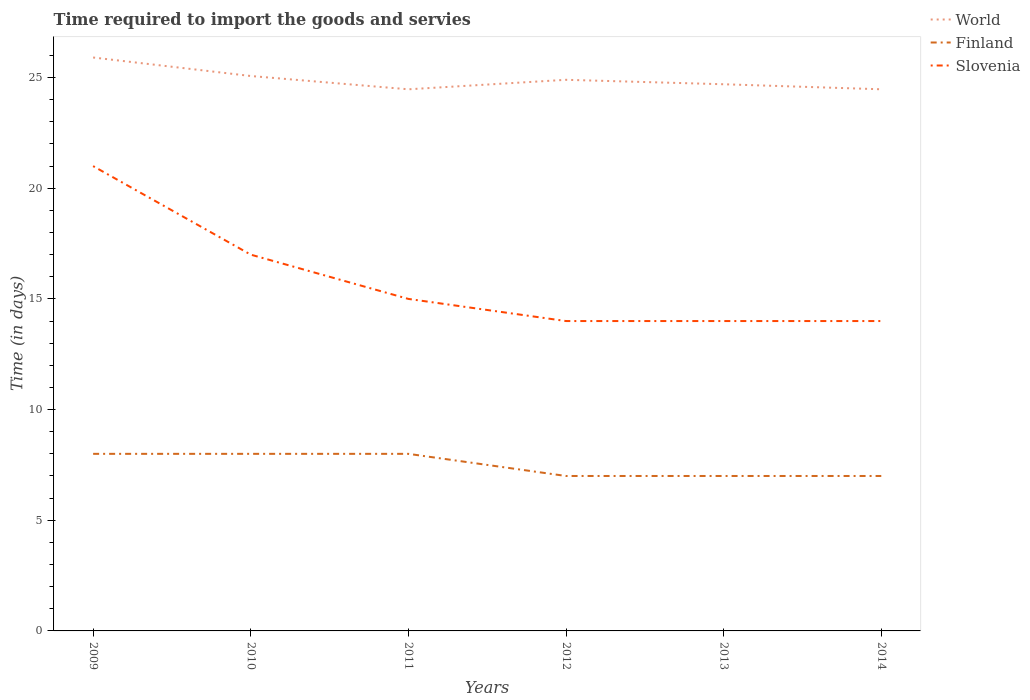How many different coloured lines are there?
Make the answer very short. 3. Does the line corresponding to World intersect with the line corresponding to Finland?
Provide a succinct answer. No. Across all years, what is the maximum number of days required to import the goods and services in Slovenia?
Ensure brevity in your answer.  14. What is the total number of days required to import the goods and services in Slovenia in the graph?
Keep it short and to the point. 4. What is the difference between the highest and the second highest number of days required to import the goods and services in Slovenia?
Keep it short and to the point. 7. What is the difference between the highest and the lowest number of days required to import the goods and services in World?
Provide a succinct answer. 2. How many lines are there?
Provide a succinct answer. 3. How many years are there in the graph?
Make the answer very short. 6. Does the graph contain grids?
Ensure brevity in your answer.  No. How are the legend labels stacked?
Your answer should be compact. Vertical. What is the title of the graph?
Ensure brevity in your answer.  Time required to import the goods and servies. Does "Bhutan" appear as one of the legend labels in the graph?
Provide a short and direct response. No. What is the label or title of the X-axis?
Your answer should be compact. Years. What is the label or title of the Y-axis?
Offer a terse response. Time (in days). What is the Time (in days) of World in 2009?
Your response must be concise. 25.91. What is the Time (in days) in Finland in 2009?
Keep it short and to the point. 8. What is the Time (in days) in Slovenia in 2009?
Make the answer very short. 21. What is the Time (in days) of World in 2010?
Keep it short and to the point. 25.07. What is the Time (in days) of Slovenia in 2010?
Your answer should be compact. 17. What is the Time (in days) in World in 2011?
Ensure brevity in your answer.  24.47. What is the Time (in days) in Finland in 2011?
Your response must be concise. 8. What is the Time (in days) in Slovenia in 2011?
Keep it short and to the point. 15. What is the Time (in days) of World in 2012?
Provide a short and direct response. 24.9. What is the Time (in days) in Finland in 2012?
Your answer should be very brief. 7. What is the Time (in days) in World in 2013?
Ensure brevity in your answer.  24.7. What is the Time (in days) of Slovenia in 2013?
Your answer should be very brief. 14. What is the Time (in days) of World in 2014?
Provide a succinct answer. 24.47. What is the Time (in days) of Finland in 2014?
Keep it short and to the point. 7. What is the Time (in days) of Slovenia in 2014?
Your answer should be very brief. 14. Across all years, what is the maximum Time (in days) in World?
Provide a short and direct response. 25.91. Across all years, what is the maximum Time (in days) of Finland?
Give a very brief answer. 8. Across all years, what is the maximum Time (in days) of Slovenia?
Offer a terse response. 21. Across all years, what is the minimum Time (in days) of World?
Give a very brief answer. 24.47. Across all years, what is the minimum Time (in days) of Slovenia?
Ensure brevity in your answer.  14. What is the total Time (in days) in World in the graph?
Ensure brevity in your answer.  149.52. What is the difference between the Time (in days) of World in 2009 and that in 2010?
Provide a short and direct response. 0.84. What is the difference between the Time (in days) in Slovenia in 2009 and that in 2010?
Your response must be concise. 4. What is the difference between the Time (in days) of World in 2009 and that in 2011?
Offer a very short reply. 1.44. What is the difference between the Time (in days) in Finland in 2009 and that in 2011?
Your answer should be compact. 0. What is the difference between the Time (in days) in Slovenia in 2009 and that in 2011?
Provide a succinct answer. 6. What is the difference between the Time (in days) of World in 2009 and that in 2012?
Your response must be concise. 1.01. What is the difference between the Time (in days) in Finland in 2009 and that in 2012?
Your response must be concise. 1. What is the difference between the Time (in days) of Slovenia in 2009 and that in 2012?
Offer a very short reply. 7. What is the difference between the Time (in days) in World in 2009 and that in 2013?
Keep it short and to the point. 1.21. What is the difference between the Time (in days) of Finland in 2009 and that in 2013?
Give a very brief answer. 1. What is the difference between the Time (in days) of Slovenia in 2009 and that in 2013?
Make the answer very short. 7. What is the difference between the Time (in days) of World in 2009 and that in 2014?
Make the answer very short. 1.44. What is the difference between the Time (in days) of Finland in 2009 and that in 2014?
Offer a very short reply. 1. What is the difference between the Time (in days) in World in 2010 and that in 2011?
Your answer should be very brief. 0.6. What is the difference between the Time (in days) in Finland in 2010 and that in 2011?
Provide a short and direct response. 0. What is the difference between the Time (in days) in World in 2010 and that in 2012?
Ensure brevity in your answer.  0.17. What is the difference between the Time (in days) of Finland in 2010 and that in 2012?
Your response must be concise. 1. What is the difference between the Time (in days) in Slovenia in 2010 and that in 2012?
Provide a short and direct response. 3. What is the difference between the Time (in days) of World in 2010 and that in 2013?
Your response must be concise. 0.37. What is the difference between the Time (in days) in Finland in 2010 and that in 2013?
Your response must be concise. 1. What is the difference between the Time (in days) in World in 2010 and that in 2014?
Your answer should be compact. 0.6. What is the difference between the Time (in days) of Slovenia in 2010 and that in 2014?
Offer a very short reply. 3. What is the difference between the Time (in days) in World in 2011 and that in 2012?
Offer a terse response. -0.43. What is the difference between the Time (in days) in Finland in 2011 and that in 2012?
Offer a terse response. 1. What is the difference between the Time (in days) of Slovenia in 2011 and that in 2012?
Your answer should be very brief. 1. What is the difference between the Time (in days) of World in 2011 and that in 2013?
Offer a terse response. -0.23. What is the difference between the Time (in days) of Finland in 2011 and that in 2013?
Your answer should be compact. 1. What is the difference between the Time (in days) in World in 2011 and that in 2014?
Give a very brief answer. -0. What is the difference between the Time (in days) of Slovenia in 2011 and that in 2014?
Ensure brevity in your answer.  1. What is the difference between the Time (in days) of World in 2012 and that in 2013?
Provide a succinct answer. 0.2. What is the difference between the Time (in days) in Finland in 2012 and that in 2013?
Give a very brief answer. 0. What is the difference between the Time (in days) of World in 2012 and that in 2014?
Make the answer very short. 0.43. What is the difference between the Time (in days) in Finland in 2012 and that in 2014?
Provide a short and direct response. 0. What is the difference between the Time (in days) of World in 2013 and that in 2014?
Offer a terse response. 0.23. What is the difference between the Time (in days) in World in 2009 and the Time (in days) in Finland in 2010?
Keep it short and to the point. 17.91. What is the difference between the Time (in days) in World in 2009 and the Time (in days) in Slovenia in 2010?
Offer a very short reply. 8.91. What is the difference between the Time (in days) of World in 2009 and the Time (in days) of Finland in 2011?
Your answer should be very brief. 17.91. What is the difference between the Time (in days) in World in 2009 and the Time (in days) in Slovenia in 2011?
Ensure brevity in your answer.  10.91. What is the difference between the Time (in days) of Finland in 2009 and the Time (in days) of Slovenia in 2011?
Your answer should be very brief. -7. What is the difference between the Time (in days) in World in 2009 and the Time (in days) in Finland in 2012?
Offer a very short reply. 18.91. What is the difference between the Time (in days) in World in 2009 and the Time (in days) in Slovenia in 2012?
Offer a very short reply. 11.91. What is the difference between the Time (in days) in Finland in 2009 and the Time (in days) in Slovenia in 2012?
Make the answer very short. -6. What is the difference between the Time (in days) of World in 2009 and the Time (in days) of Finland in 2013?
Your answer should be very brief. 18.91. What is the difference between the Time (in days) in World in 2009 and the Time (in days) in Slovenia in 2013?
Your answer should be very brief. 11.91. What is the difference between the Time (in days) in Finland in 2009 and the Time (in days) in Slovenia in 2013?
Provide a succinct answer. -6. What is the difference between the Time (in days) of World in 2009 and the Time (in days) of Finland in 2014?
Your response must be concise. 18.91. What is the difference between the Time (in days) of World in 2009 and the Time (in days) of Slovenia in 2014?
Provide a succinct answer. 11.91. What is the difference between the Time (in days) in Finland in 2009 and the Time (in days) in Slovenia in 2014?
Your response must be concise. -6. What is the difference between the Time (in days) in World in 2010 and the Time (in days) in Finland in 2011?
Give a very brief answer. 17.07. What is the difference between the Time (in days) in World in 2010 and the Time (in days) in Slovenia in 2011?
Offer a very short reply. 10.07. What is the difference between the Time (in days) in World in 2010 and the Time (in days) in Finland in 2012?
Ensure brevity in your answer.  18.07. What is the difference between the Time (in days) of World in 2010 and the Time (in days) of Slovenia in 2012?
Ensure brevity in your answer.  11.07. What is the difference between the Time (in days) of Finland in 2010 and the Time (in days) of Slovenia in 2012?
Keep it short and to the point. -6. What is the difference between the Time (in days) in World in 2010 and the Time (in days) in Finland in 2013?
Your answer should be very brief. 18.07. What is the difference between the Time (in days) in World in 2010 and the Time (in days) in Slovenia in 2013?
Ensure brevity in your answer.  11.07. What is the difference between the Time (in days) of World in 2010 and the Time (in days) of Finland in 2014?
Give a very brief answer. 18.07. What is the difference between the Time (in days) in World in 2010 and the Time (in days) in Slovenia in 2014?
Give a very brief answer. 11.07. What is the difference between the Time (in days) in World in 2011 and the Time (in days) in Finland in 2012?
Your answer should be very brief. 17.47. What is the difference between the Time (in days) of World in 2011 and the Time (in days) of Slovenia in 2012?
Provide a short and direct response. 10.47. What is the difference between the Time (in days) of World in 2011 and the Time (in days) of Finland in 2013?
Your answer should be very brief. 17.47. What is the difference between the Time (in days) in World in 2011 and the Time (in days) in Slovenia in 2013?
Make the answer very short. 10.47. What is the difference between the Time (in days) in Finland in 2011 and the Time (in days) in Slovenia in 2013?
Provide a short and direct response. -6. What is the difference between the Time (in days) in World in 2011 and the Time (in days) in Finland in 2014?
Offer a very short reply. 17.47. What is the difference between the Time (in days) in World in 2011 and the Time (in days) in Slovenia in 2014?
Provide a succinct answer. 10.47. What is the difference between the Time (in days) of World in 2012 and the Time (in days) of Finland in 2013?
Offer a very short reply. 17.9. What is the difference between the Time (in days) of World in 2012 and the Time (in days) of Slovenia in 2013?
Make the answer very short. 10.9. What is the difference between the Time (in days) in World in 2012 and the Time (in days) in Finland in 2014?
Make the answer very short. 17.9. What is the difference between the Time (in days) in World in 2012 and the Time (in days) in Slovenia in 2014?
Your response must be concise. 10.9. What is the difference between the Time (in days) of World in 2013 and the Time (in days) of Finland in 2014?
Your response must be concise. 17.7. What is the difference between the Time (in days) of World in 2013 and the Time (in days) of Slovenia in 2014?
Your answer should be compact. 10.7. What is the difference between the Time (in days) in Finland in 2013 and the Time (in days) in Slovenia in 2014?
Give a very brief answer. -7. What is the average Time (in days) in World per year?
Offer a terse response. 24.92. What is the average Time (in days) in Slovenia per year?
Your answer should be very brief. 15.83. In the year 2009, what is the difference between the Time (in days) of World and Time (in days) of Finland?
Provide a short and direct response. 17.91. In the year 2009, what is the difference between the Time (in days) in World and Time (in days) in Slovenia?
Your answer should be very brief. 4.91. In the year 2010, what is the difference between the Time (in days) in World and Time (in days) in Finland?
Your answer should be very brief. 17.07. In the year 2010, what is the difference between the Time (in days) in World and Time (in days) in Slovenia?
Your response must be concise. 8.07. In the year 2010, what is the difference between the Time (in days) of Finland and Time (in days) of Slovenia?
Offer a very short reply. -9. In the year 2011, what is the difference between the Time (in days) in World and Time (in days) in Finland?
Ensure brevity in your answer.  16.47. In the year 2011, what is the difference between the Time (in days) of World and Time (in days) of Slovenia?
Offer a terse response. 9.47. In the year 2012, what is the difference between the Time (in days) of World and Time (in days) of Finland?
Your answer should be very brief. 17.9. In the year 2012, what is the difference between the Time (in days) of World and Time (in days) of Slovenia?
Provide a short and direct response. 10.9. In the year 2012, what is the difference between the Time (in days) in Finland and Time (in days) in Slovenia?
Ensure brevity in your answer.  -7. In the year 2013, what is the difference between the Time (in days) in World and Time (in days) in Finland?
Make the answer very short. 17.7. In the year 2013, what is the difference between the Time (in days) in World and Time (in days) in Slovenia?
Your answer should be very brief. 10.7. In the year 2014, what is the difference between the Time (in days) of World and Time (in days) of Finland?
Keep it short and to the point. 17.47. In the year 2014, what is the difference between the Time (in days) in World and Time (in days) in Slovenia?
Give a very brief answer. 10.47. In the year 2014, what is the difference between the Time (in days) in Finland and Time (in days) in Slovenia?
Keep it short and to the point. -7. What is the ratio of the Time (in days) in World in 2009 to that in 2010?
Keep it short and to the point. 1.03. What is the ratio of the Time (in days) of Slovenia in 2009 to that in 2010?
Ensure brevity in your answer.  1.24. What is the ratio of the Time (in days) of World in 2009 to that in 2011?
Your answer should be compact. 1.06. What is the ratio of the Time (in days) of World in 2009 to that in 2012?
Your answer should be very brief. 1.04. What is the ratio of the Time (in days) of World in 2009 to that in 2013?
Offer a terse response. 1.05. What is the ratio of the Time (in days) in World in 2009 to that in 2014?
Give a very brief answer. 1.06. What is the ratio of the Time (in days) in World in 2010 to that in 2011?
Offer a very short reply. 1.02. What is the ratio of the Time (in days) of Slovenia in 2010 to that in 2011?
Provide a short and direct response. 1.13. What is the ratio of the Time (in days) in Finland in 2010 to that in 2012?
Provide a succinct answer. 1.14. What is the ratio of the Time (in days) in Slovenia in 2010 to that in 2012?
Provide a succinct answer. 1.21. What is the ratio of the Time (in days) in World in 2010 to that in 2013?
Ensure brevity in your answer.  1.02. What is the ratio of the Time (in days) of Slovenia in 2010 to that in 2013?
Your response must be concise. 1.21. What is the ratio of the Time (in days) in World in 2010 to that in 2014?
Make the answer very short. 1.02. What is the ratio of the Time (in days) of Finland in 2010 to that in 2014?
Your answer should be very brief. 1.14. What is the ratio of the Time (in days) in Slovenia in 2010 to that in 2014?
Your answer should be compact. 1.21. What is the ratio of the Time (in days) of World in 2011 to that in 2012?
Your response must be concise. 0.98. What is the ratio of the Time (in days) in Slovenia in 2011 to that in 2012?
Offer a very short reply. 1.07. What is the ratio of the Time (in days) of World in 2011 to that in 2013?
Provide a short and direct response. 0.99. What is the ratio of the Time (in days) of Finland in 2011 to that in 2013?
Your answer should be compact. 1.14. What is the ratio of the Time (in days) of Slovenia in 2011 to that in 2013?
Offer a terse response. 1.07. What is the ratio of the Time (in days) of World in 2011 to that in 2014?
Make the answer very short. 1. What is the ratio of the Time (in days) of Slovenia in 2011 to that in 2014?
Make the answer very short. 1.07. What is the ratio of the Time (in days) of World in 2012 to that in 2013?
Your answer should be very brief. 1.01. What is the ratio of the Time (in days) in Slovenia in 2012 to that in 2013?
Keep it short and to the point. 1. What is the ratio of the Time (in days) in World in 2012 to that in 2014?
Give a very brief answer. 1.02. What is the ratio of the Time (in days) in Finland in 2012 to that in 2014?
Keep it short and to the point. 1. What is the ratio of the Time (in days) in World in 2013 to that in 2014?
Provide a succinct answer. 1.01. What is the difference between the highest and the second highest Time (in days) of World?
Your answer should be compact. 0.84. What is the difference between the highest and the second highest Time (in days) of Finland?
Make the answer very short. 0. What is the difference between the highest and the lowest Time (in days) in World?
Ensure brevity in your answer.  1.44. What is the difference between the highest and the lowest Time (in days) in Finland?
Make the answer very short. 1. 